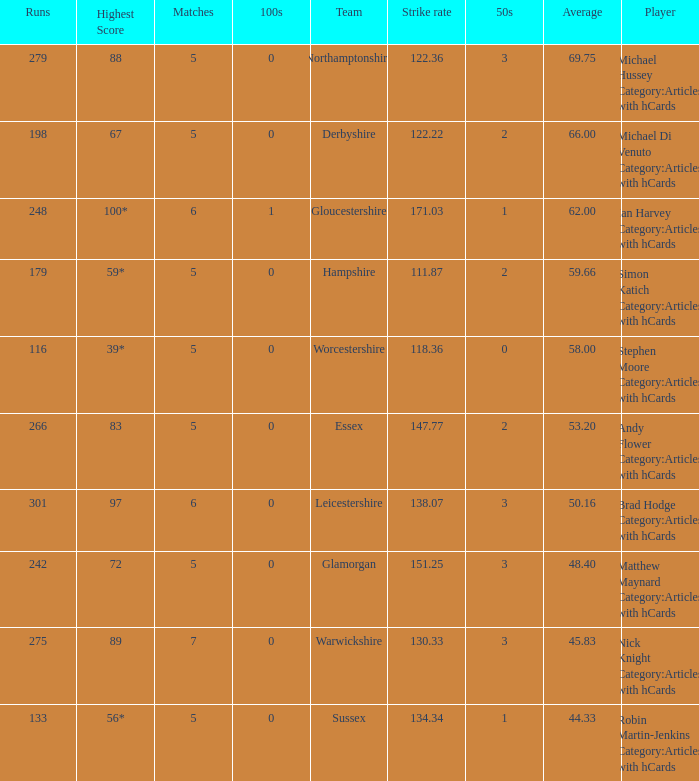What is the smallest amount of matches? 5.0. Can you parse all the data within this table? {'header': ['Runs', 'Highest Score', 'Matches', '100s', 'Team', 'Strike rate', '50s', 'Average', 'Player'], 'rows': [['279', '88', '5', '0', 'Northamptonshire', '122.36', '3', '69.75', 'Michael Hussey Category:Articles with hCards'], ['198', '67', '5', '0', 'Derbyshire', '122.22', '2', '66.00', 'Michael Di Venuto Category:Articles with hCards'], ['248', '100*', '6', '1', 'Gloucestershire', '171.03', '1', '62.00', 'Ian Harvey Category:Articles with hCards'], ['179', '59*', '5', '0', 'Hampshire', '111.87', '2', '59.66', 'Simon Katich Category:Articles with hCards'], ['116', '39*', '5', '0', 'Worcestershire', '118.36', '0', '58.00', 'Stephen Moore Category:Articles with hCards'], ['266', '83', '5', '0', 'Essex', '147.77', '2', '53.20', 'Andy Flower Category:Articles with hCards'], ['301', '97', '6', '0', 'Leicestershire', '138.07', '3', '50.16', 'Brad Hodge Category:Articles with hCards'], ['242', '72', '5', '0', 'Glamorgan', '151.25', '3', '48.40', 'Matthew Maynard Category:Articles with hCards'], ['275', '89', '7', '0', 'Warwickshire', '130.33', '3', '45.83', 'Nick Knight Category:Articles with hCards'], ['133', '56*', '5', '0', 'Sussex', '134.34', '1', '44.33', 'Robin Martin-Jenkins Category:Articles with hCards']]} 